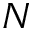Convert formula to latex. <formula><loc_0><loc_0><loc_500><loc_500>N</formula> 